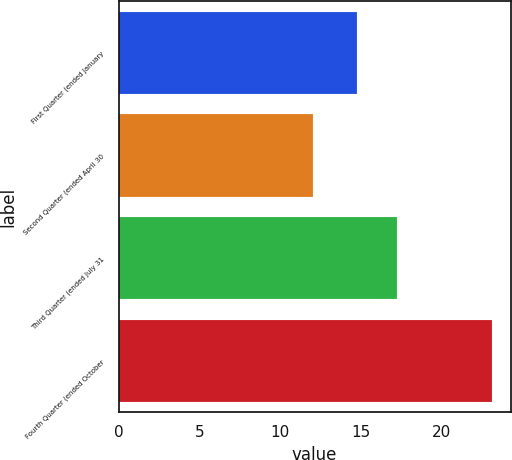Convert chart to OTSL. <chart><loc_0><loc_0><loc_500><loc_500><bar_chart><fcel>First Quarter (ended January<fcel>Second Quarter (ended April 30<fcel>Third Quarter (ended July 31<fcel>Fourth Quarter (ended October<nl><fcel>14.76<fcel>12.02<fcel>17.26<fcel>23.14<nl></chart> 